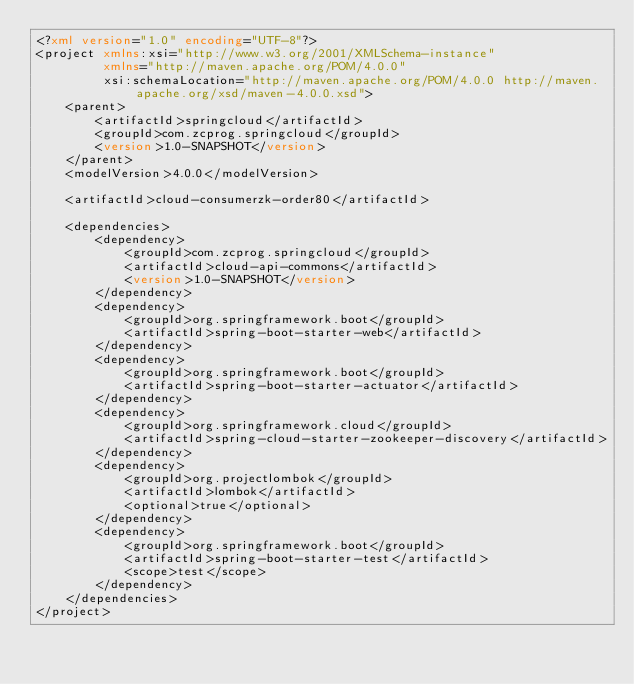Convert code to text. <code><loc_0><loc_0><loc_500><loc_500><_XML_><?xml version="1.0" encoding="UTF-8"?>
<project xmlns:xsi="http://www.w3.org/2001/XMLSchema-instance"
         xmlns="http://maven.apache.org/POM/4.0.0"
         xsi:schemaLocation="http://maven.apache.org/POM/4.0.0 http://maven.apache.org/xsd/maven-4.0.0.xsd">
    <parent>
        <artifactId>springcloud</artifactId>
        <groupId>com.zcprog.springcloud</groupId>
        <version>1.0-SNAPSHOT</version>
    </parent>
    <modelVersion>4.0.0</modelVersion>

    <artifactId>cloud-consumerzk-order80</artifactId>

    <dependencies>
        <dependency>
            <groupId>com.zcprog.springcloud</groupId>
            <artifactId>cloud-api-commons</artifactId>
            <version>1.0-SNAPSHOT</version>
        </dependency>
        <dependency>
            <groupId>org.springframework.boot</groupId>
            <artifactId>spring-boot-starter-web</artifactId>
        </dependency>
        <dependency>
            <groupId>org.springframework.boot</groupId>
            <artifactId>spring-boot-starter-actuator</artifactId>
        </dependency>
        <dependency>
            <groupId>org.springframework.cloud</groupId>
            <artifactId>spring-cloud-starter-zookeeper-discovery</artifactId>
        </dependency>
        <dependency>
            <groupId>org.projectlombok</groupId>
            <artifactId>lombok</artifactId>
            <optional>true</optional>
        </dependency>
        <dependency>
            <groupId>org.springframework.boot</groupId>
            <artifactId>spring-boot-starter-test</artifactId>
            <scope>test</scope>
        </dependency>
    </dependencies>
</project>
</code> 